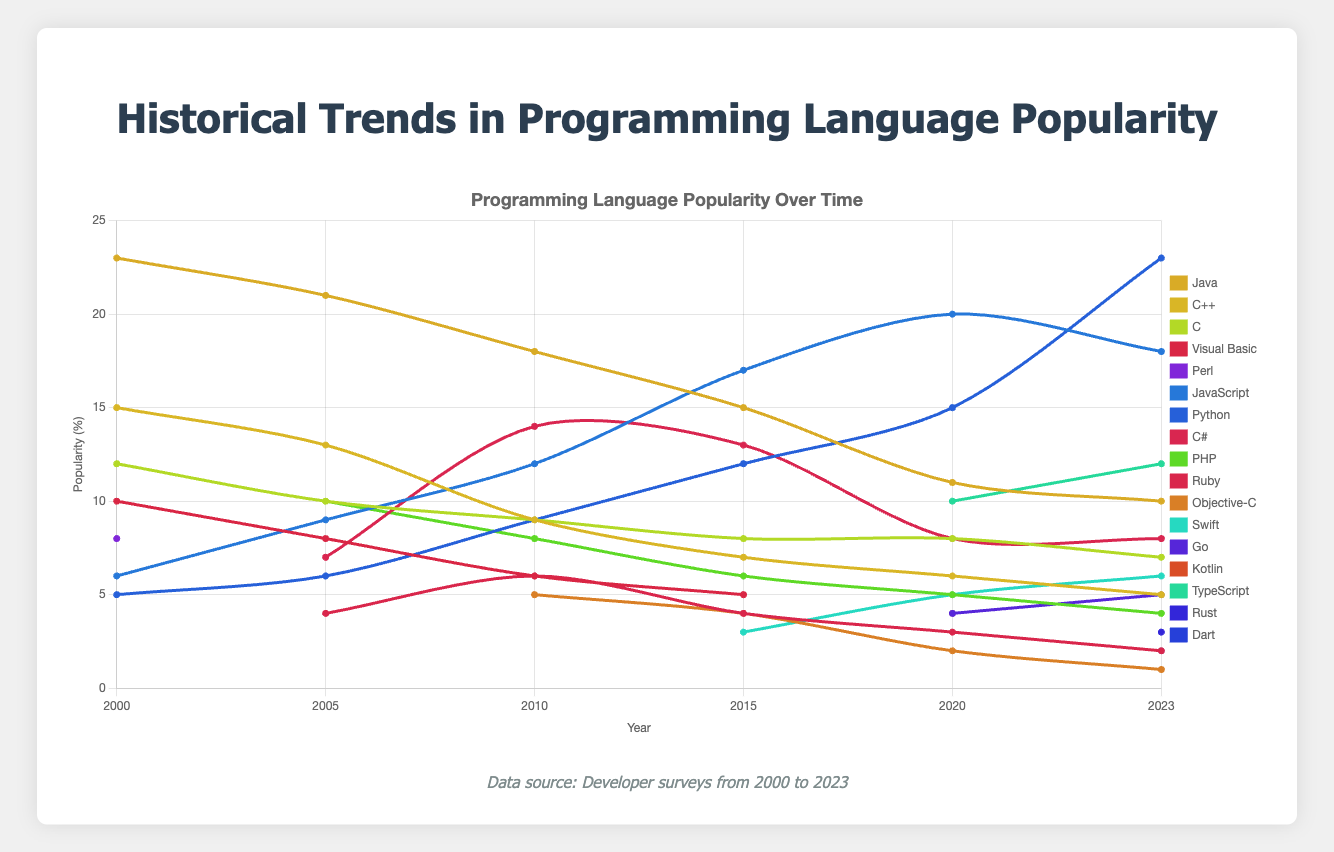Which language saw the highest increase in popularity from 2020 to 2023? To determine the highest increase, subtract each language's popularity value in 2020 from its corresponding value in 2023. Python increased from 15% to 23%, a difference of 8%, which is higher than any other language.
Answer: Python Comparing Java and JavaScript, which one maintained a higher average popularity from 2000 to 2023? Calculate the average popularity for both Java and JavaScript by adding their respective values and dividing by the number of years (6). Java's sum (23+21+18+15+11+10) is 98, average is 98/6 ≈ 16.33. JavaScript's sum (6+9+12+17+20+18) is 82, average is 82/6 ≈ 13.67.
Answer: Java What is the combined popularity of Python and JavaScript in 2023? Add the 2023 popularity values of Python (23%) and JavaScript (18%). The combined total is 23 + 18.
Answer: 41 Which programming language had the steepest decline in popularity between 2005 and 2010? Determine the decline for each language by subtracting the 2010 value from the 2005 value. For Visual Basic, the drop is 8-6=2. For C++, it's 13-9=4. The steepest decline is for Java, from 21 in 2005 to 18 in 2010, a drop of 21-18=3. So, the steepest decline is for C++ with 4.
Answer: C++ Which was more popular in 2023: TypeScript or Swift? Compare the 2023 popularity values of TypeScript (12%) and Swift (6%).
Answer: TypeScript Considering the trend from 2000 to 2023, which programming language showed consistent growth without any dips? Check each language's values year by year. Python's values (5, 6, 9, 12, 15, 23) show a consistent increase across all years, indicating steady growth.
Answer: Python In which year did Perl fall out of the top list of popular languages and did not reappear? Perl was listed in the year 2000 but did not appear in subsequent years, so the transition year is after 2000.
Answer: 2005 Comparing 2000 and 2023, which language made the most noticeable entrance into the list? Check the languages in 2000 that were not there and appeared in 2023. TypeScript appeared newly in 2020 with 10% and maintained popularity (12%). Rust and Dart also entered, but TypeScript has the largest share in 2023.
Answer: TypeScript Among the new languages that appeared post-2010, which had the highest popularity by 2023? Identify languages added after 2010 (Swift, Go, Kotlin, TypeScript, Rust, Dart) and check their 2023 values. TypeScript has the highest with 12%.
Answer: TypeScript Considering the year 2015, which three languages were equally ranked fifth in terms of popularity? Identify languages with the same value for ranking in 2015. Visual Basic, PHP, and Ruby all have popularity values of 5.
Answer: Visual Basic, PHP, Ruby 